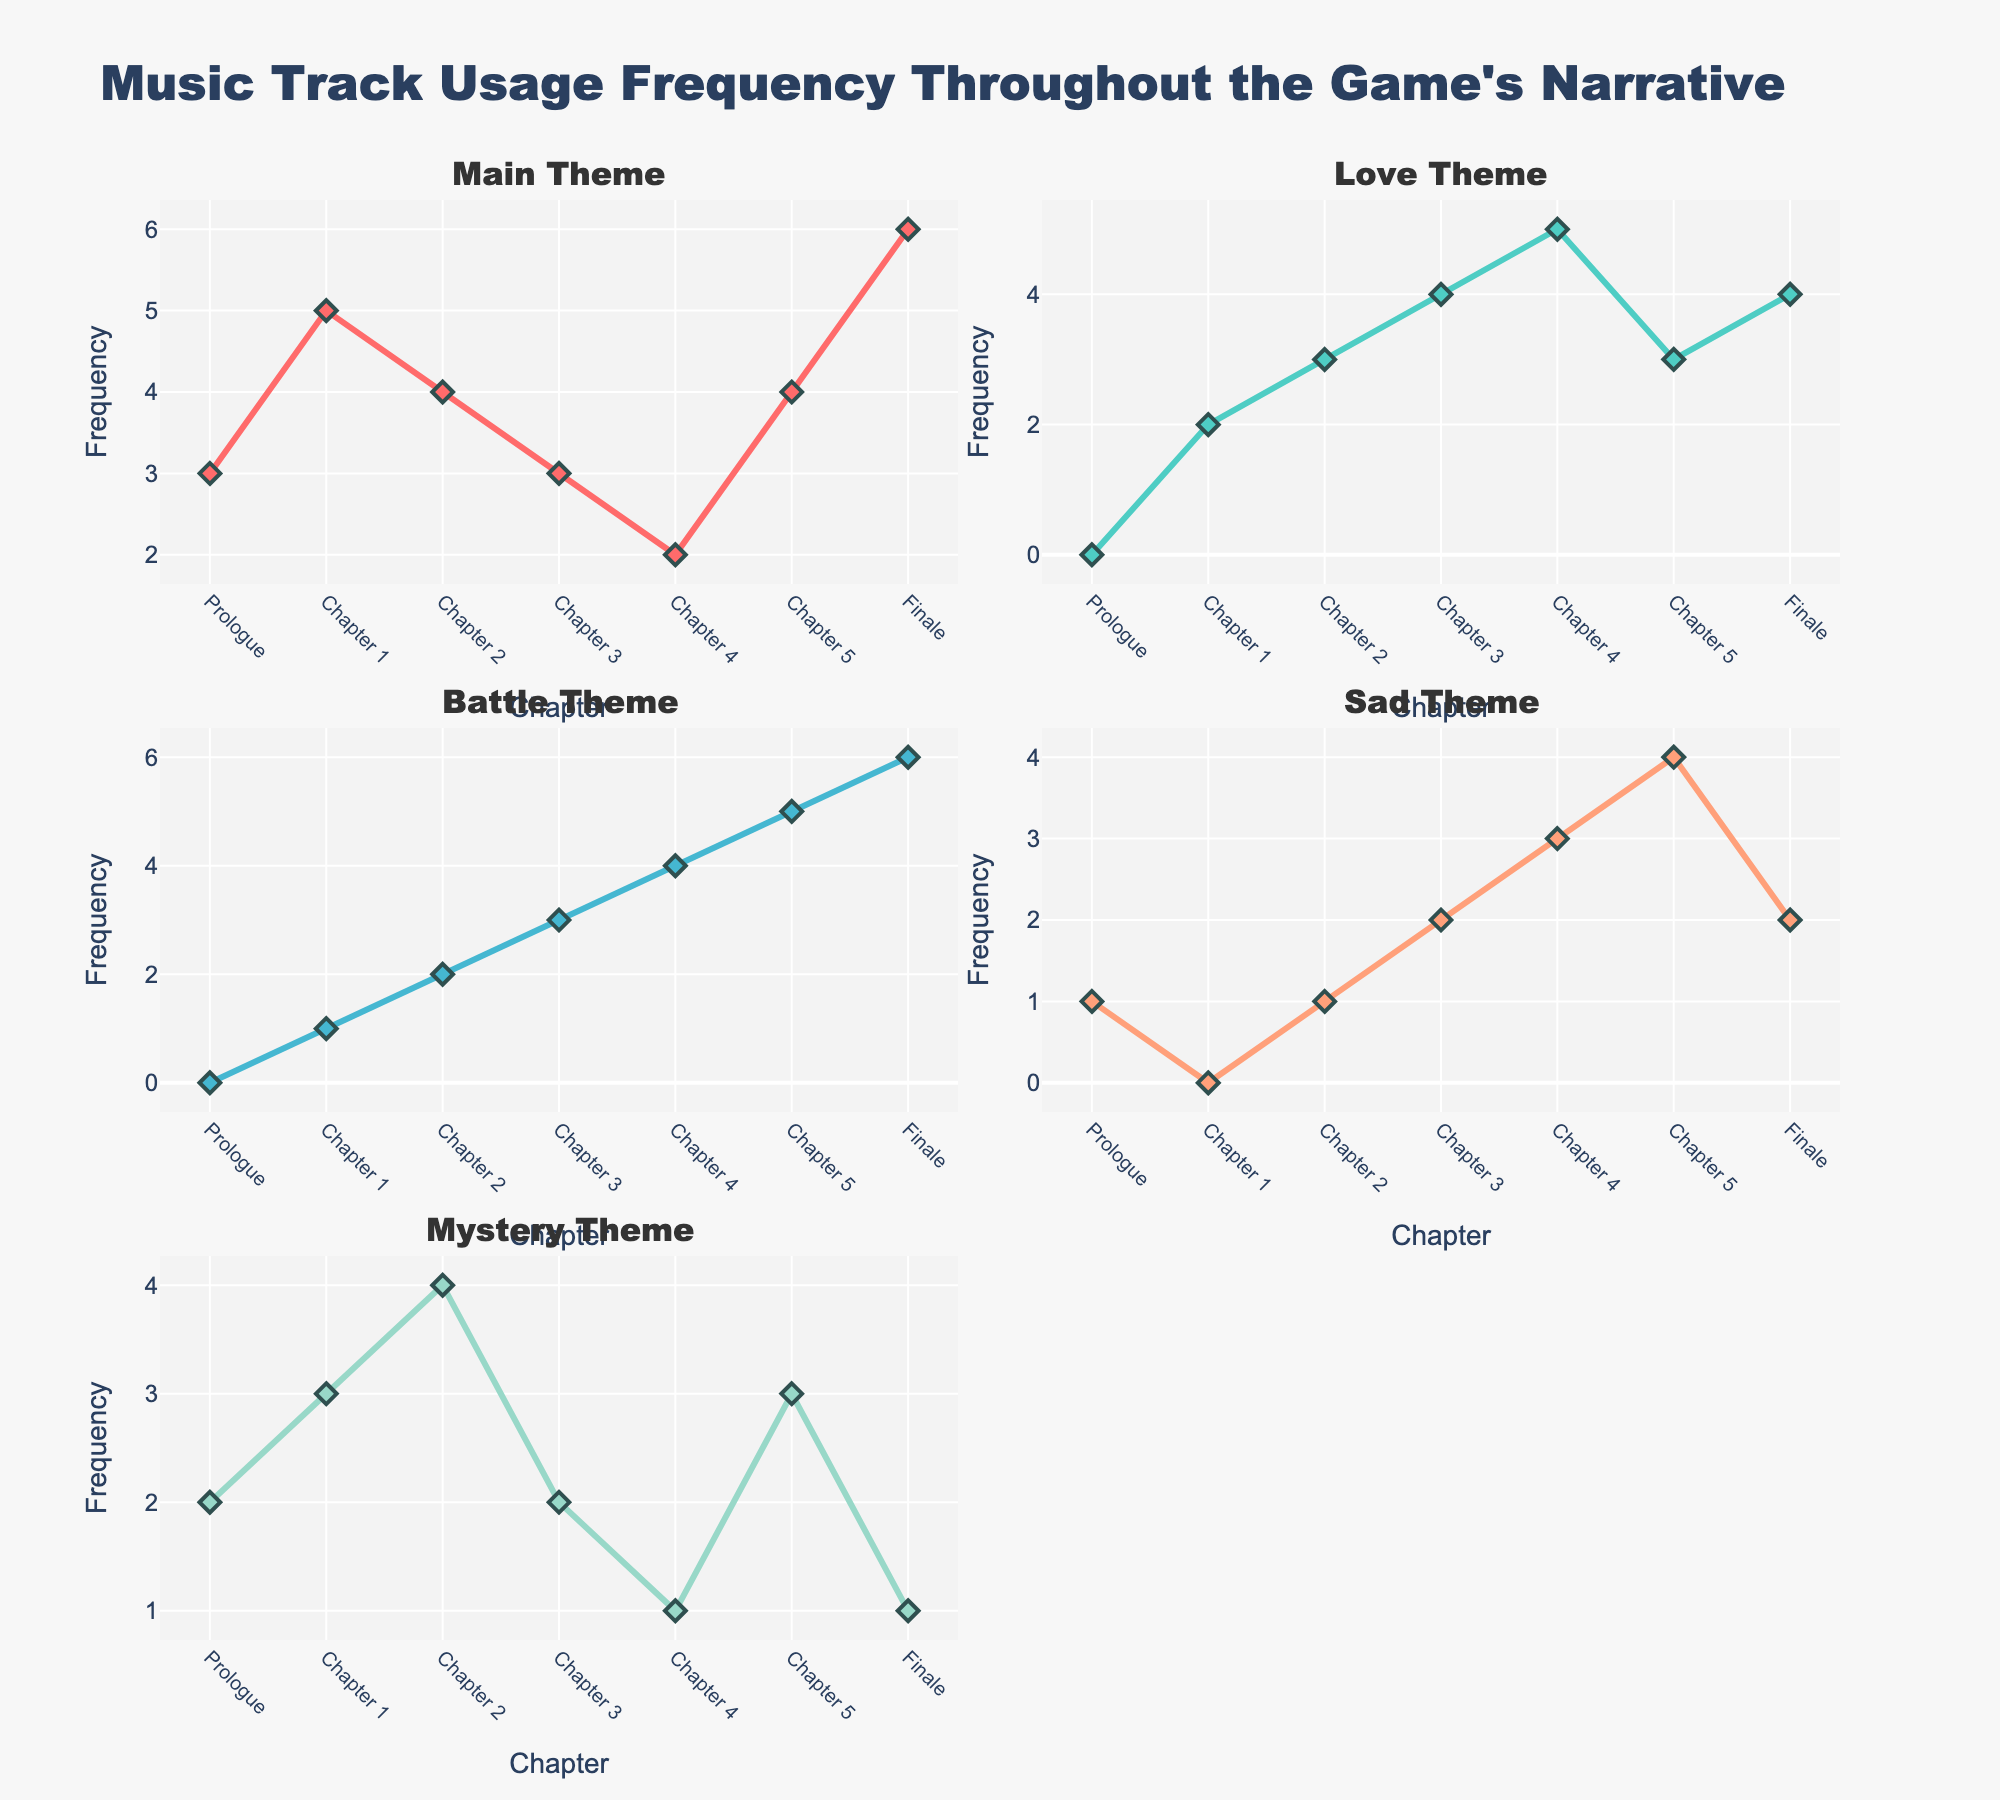What is the title of the figure? The title is displayed at the top of the figure, typically in a larger or bold font to distinguish it as the main heading of the chart. In this case, the title reads "Music Track Usage Frequency Throughout the Game's Narrative."
Answer: "Music Track Usage Frequency Throughout the Game's Narrative" What is the frequency of the Battle Theme in Chapter 3? By looking at the subplot for the Battle Theme and finding the data point corresponding to Chapter 3, we see the frequency. It's represented by a point on the line at the y-axis value 3.
Answer: 3 Which theme has the highest frequency in the Finale? By comparing the data points for all themes in the Finale chapter, we note that the Main Theme has the highest y-axis value with a frequency of 6.
Answer: Main Theme What is the average frequency of the Love Theme across all chapters? The frequencies for the Love Theme are 0, 2, 3, 4, 5, 3, and 4. Sum these values (0 + 2 + 3 + 4 + 5 + 3 + 4 = 21) and divide by the number of chapters (7). So, the average is 21/7.
Answer: 3 Is the frequency of the Main Theme always increasing, decreasing, or fluctuating throughout the chapters? Observing the trend line for the Main Theme, the frequency increases from the Prologue to Chapter 1, decreases from Chapter 1 to Chapter 4, then increases again to the Finale. Therefore, the frequency fluctuates.
Answer: Fluctuating How many data points are there for each chapter across all themes? Each subplot represents a different theme, and each theme is tracked across 7 chapters. Therefore, each chapter has 5 data points (one for each theme).
Answer: 5 Which chapter has the highest aggregate frequency for all themes combined? Sum the frequencies of all themes for each chapter. 
Prologue: 3+0+0+1+2 = 6,
Chapter 1: 5+2+1+0+3 = 11,
Chapter 2: 4+3+2+1+4= 14,
Chapter 3: 3+4+3+2+2 = 14,
Chapter 4: 2+5+4+3+1 = 15,
Chapter 5: 4+3+5+4+3 = 19,
Finale: 6+4+6+2+1 = 19,
Chapters 5 and the Finale have the highest aggregate frequency of 19.
Answer: Chapter 5, Finale By how much did the frequency of the Sad Theme increase from Chapter 3 to Chapter 5? The frequency of the Sad Theme in Chapter 3 is 2, and in Chapter 5 it is 4. Subtract the value in Chapter 3 from the value in Chapter 5 (4 - 2) to get the increase.
Answer: 2 In which chapter does the Mystery Theme have its highest frequency? By looking at the subplot for the Mystery Theme, we identify the highest data point, which is in Chapter 2 with a value of 4.
Answer: Chapter 2 What is the total frequency of the Main Theme from the Prologue to Chapter 4? Add the frequencies of the Main Theme for the specified chapters: Prologue (3) + Chapter 1 (5) + Chapter 2 (4) + Chapter 3 (3) + Chapter 4 (2) = 17.
Answer: 17 